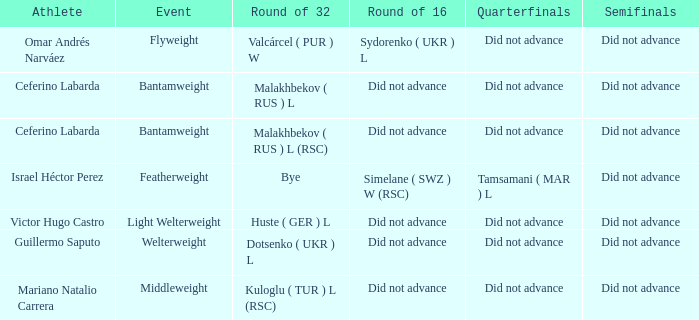Which athlete competed in the flyweight division? Omar Andrés Narváez. 